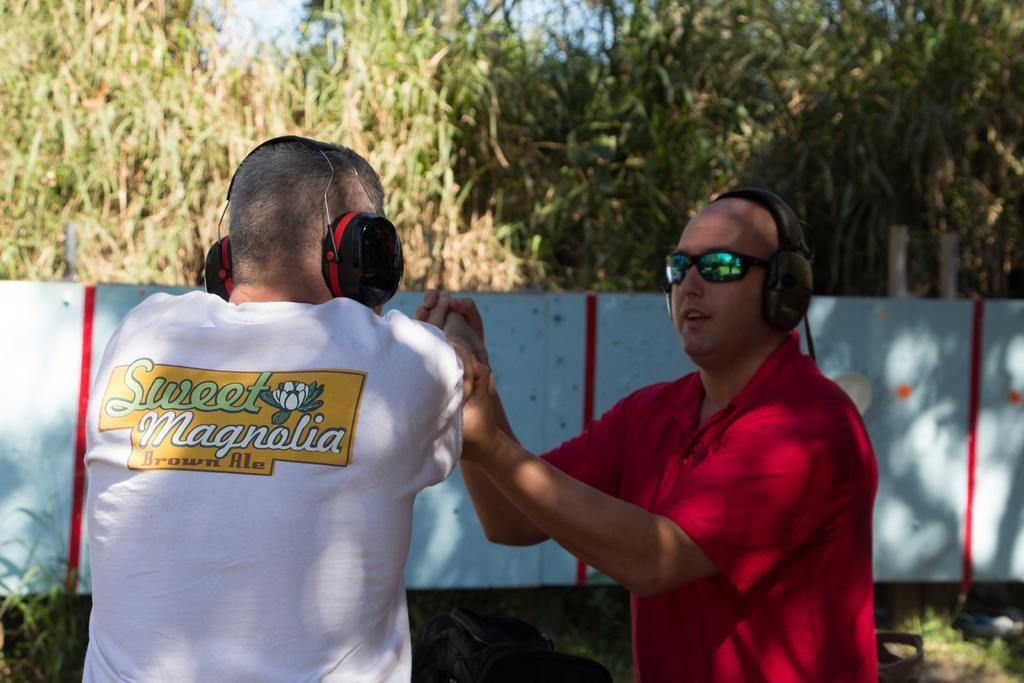Describe this image in one or two sentences. In this image I can see two men in the front and I can see both of them are wearing t shirts and headphones. I can also see the right one is wearing shades. In the background I can see blue colour wall, number of trees and the sky. On the left side I can see something is written on his dress. 